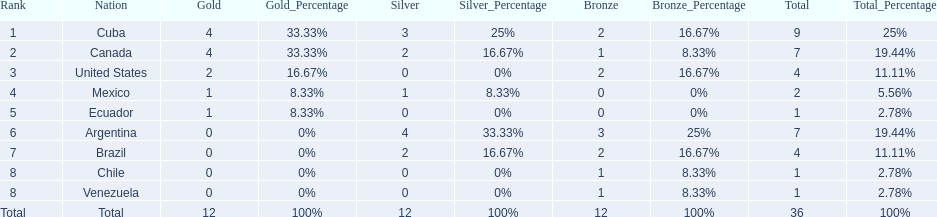Which nations won gold medals? Cuba, Canada, United States, Mexico, Ecuador. How many medals did each nation win? Cuba, 9, Canada, 7, United States, 4, Mexico, 2, Ecuador, 1. Which nation only won a gold medal? Ecuador. 